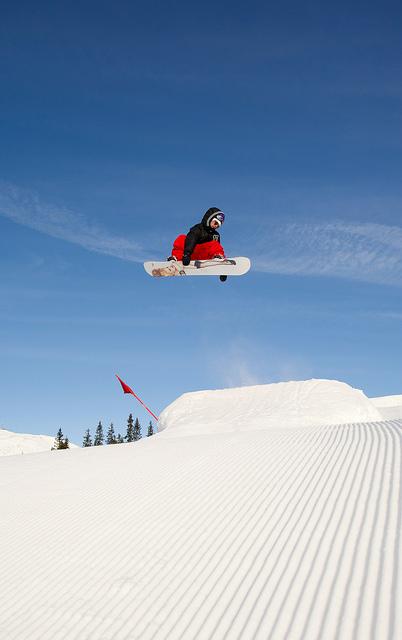What sport is this?
Keep it brief. Snowboarding. Is the snowboarder squatting?
Write a very short answer. Yes. How many people are shown?
Write a very short answer. 1. What are they doing?
Concise answer only. Snowboarding. What sport is represented in this photo?
Concise answer only. Snowboarding. 